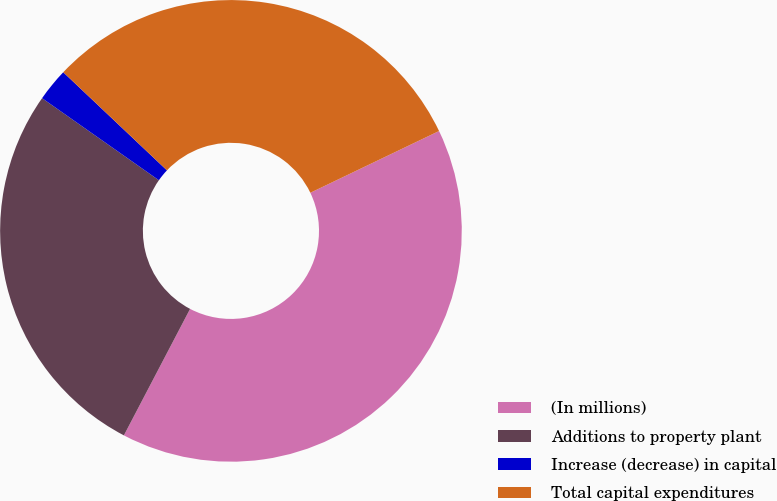<chart> <loc_0><loc_0><loc_500><loc_500><pie_chart><fcel>(In millions)<fcel>Additions to property plant<fcel>Increase (decrease) in capital<fcel>Total capital expenditures<nl><fcel>39.79%<fcel>27.07%<fcel>2.31%<fcel>30.82%<nl></chart> 